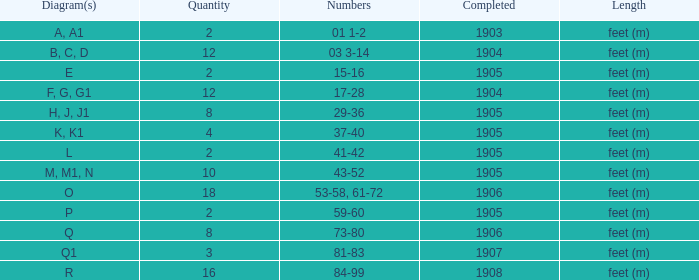For the item with more than 10, and numbers of 53-58, 61-72, what is the lowest completed? 1906.0. 